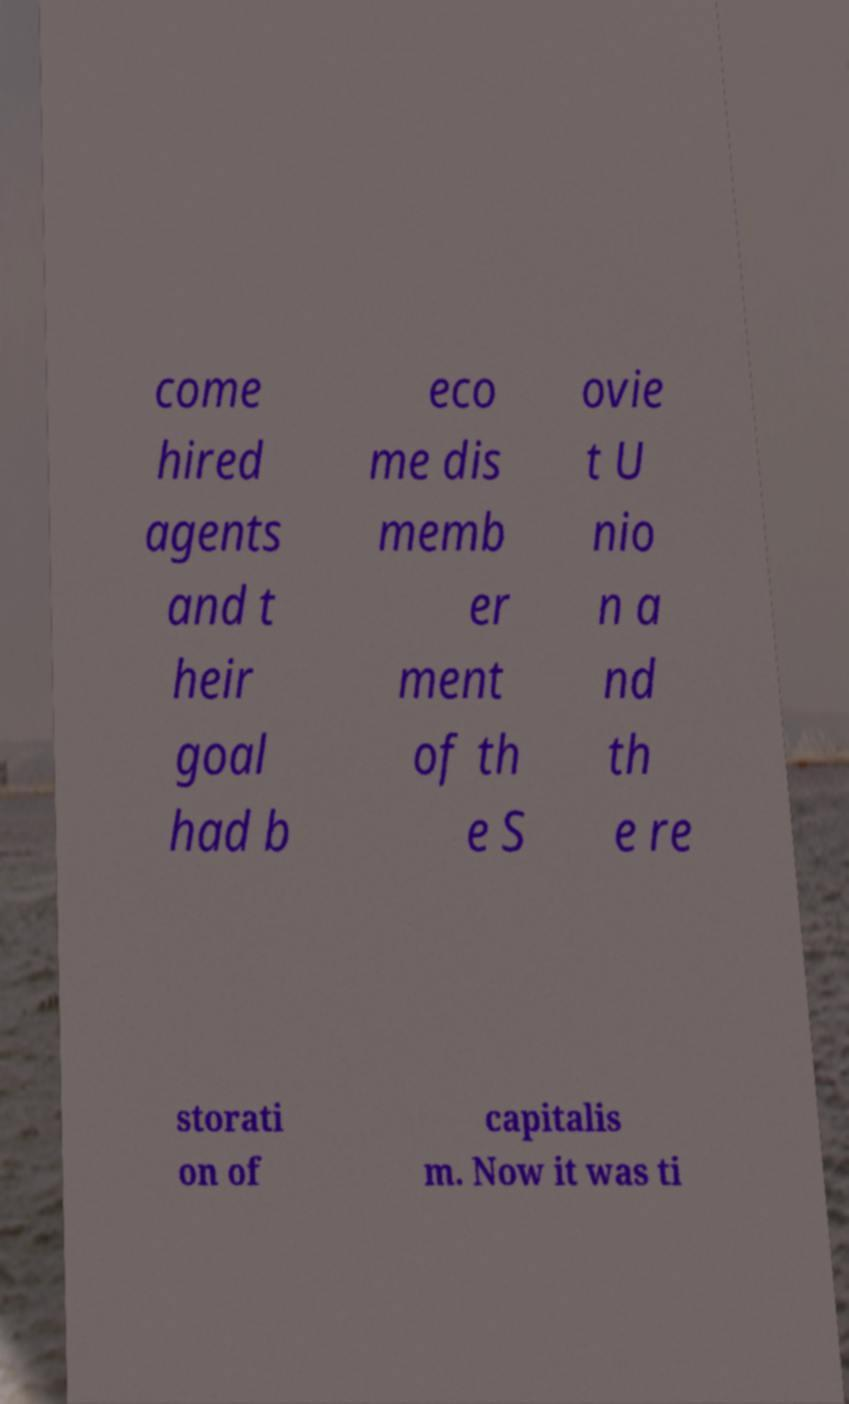Please identify and transcribe the text found in this image. come hired agents and t heir goal had b eco me dis memb er ment of th e S ovie t U nio n a nd th e re storati on of capitalis m. Now it was ti 